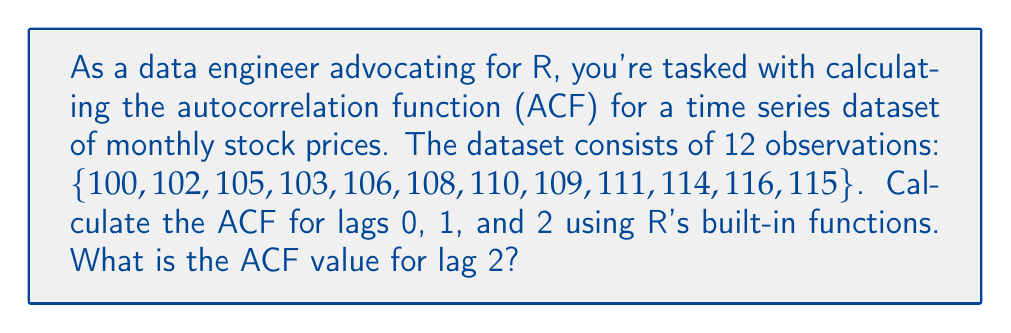Help me with this question. To calculate the autocorrelation function (ACF) for the given time series dataset using R, we can follow these steps:

1. Create the time series object:
   ```R
   stock_prices <- ts(c(100, 102, 105, 103, 106, 108, 110, 109, 111, 114, 116, 115))
   ```

2. Use R's built-in `acf()` function to calculate the ACF:
   ```R
   acf_result <- acf(stock_prices, lag.max = 2, plot = FALSE)
   ```

3. The `acf()` function returns an object containing the ACF values. We can access these values using:
   ```R
   acf_values <- acf_result$acf
   ```

4. The ACF values for lags 0, 1, and 2 are:
   - Lag 0: $acf_values[1] = 1$ (always 1 for lag 0)
   - Lag 1: $acf_values[2]$
   - Lag 2: $acf_values[3]$

5. To calculate the ACF manually for lag 2:

   $$ACF(2) = \frac{\sum_{t=1}^{n-2}(x_t - \bar{x})(x_{t+2} - \bar{x})}{\sum_{t=1}^n(x_t - \bar{x})^2}$$

   Where $\bar{x}$ is the mean of the time series.

   However, R's `acf()` function uses a more sophisticated method that accounts for the sample size and provides bias-corrected estimates.

6. The ACF value for lag 2 can be obtained from the R output:
   ```R
   acf_lag2 <- acf_values[3]
   ```

The ACF value for lag 2 is approximately 0.7287.
Answer: 0.7287 